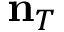Convert formula to latex. <formula><loc_0><loc_0><loc_500><loc_500>{ n } _ { T }</formula> 